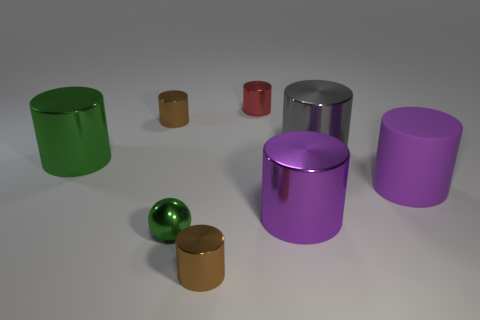Are there any balls that have the same size as the red cylinder?
Provide a short and direct response. Yes. There is a green object that is to the right of the large cylinder that is left of the red metallic object; what is its material?
Your response must be concise. Metal. What number of other matte cylinders have the same color as the big matte cylinder?
Your answer should be very brief. 0. There is a green object that is the same material as the large green cylinder; what is its shape?
Your answer should be very brief. Sphere. There is a purple object on the right side of the gray metallic object; what size is it?
Provide a short and direct response. Large. Is the number of rubber things that are behind the tiny red thing the same as the number of tiny green spheres behind the gray metallic object?
Offer a terse response. Yes. The metal cylinder that is in front of the green ball in front of the big thing to the left of the red metallic thing is what color?
Make the answer very short. Brown. How many cylinders are both to the left of the tiny red cylinder and on the right side of the metallic ball?
Ensure brevity in your answer.  1. There is a cylinder in front of the tiny green shiny sphere; is its color the same as the small shiny cylinder that is left of the small green sphere?
Provide a short and direct response. Yes. There is a purple metallic thing that is the same shape as the large green shiny thing; what size is it?
Your response must be concise. Large. 